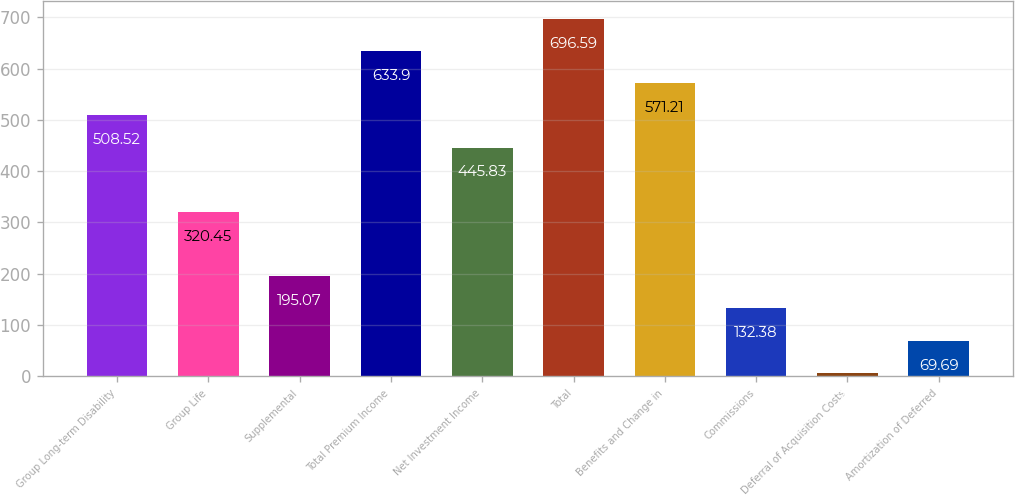<chart> <loc_0><loc_0><loc_500><loc_500><bar_chart><fcel>Group Long-term Disability<fcel>Group Life<fcel>Supplemental<fcel>Total Premium Income<fcel>Net Investment Income<fcel>Total<fcel>Benefits and Change in<fcel>Commissions<fcel>Deferral of Acquisition Costs<fcel>Amortization of Deferred<nl><fcel>508.52<fcel>320.45<fcel>195.07<fcel>633.9<fcel>445.83<fcel>696.59<fcel>571.21<fcel>132.38<fcel>7<fcel>69.69<nl></chart> 